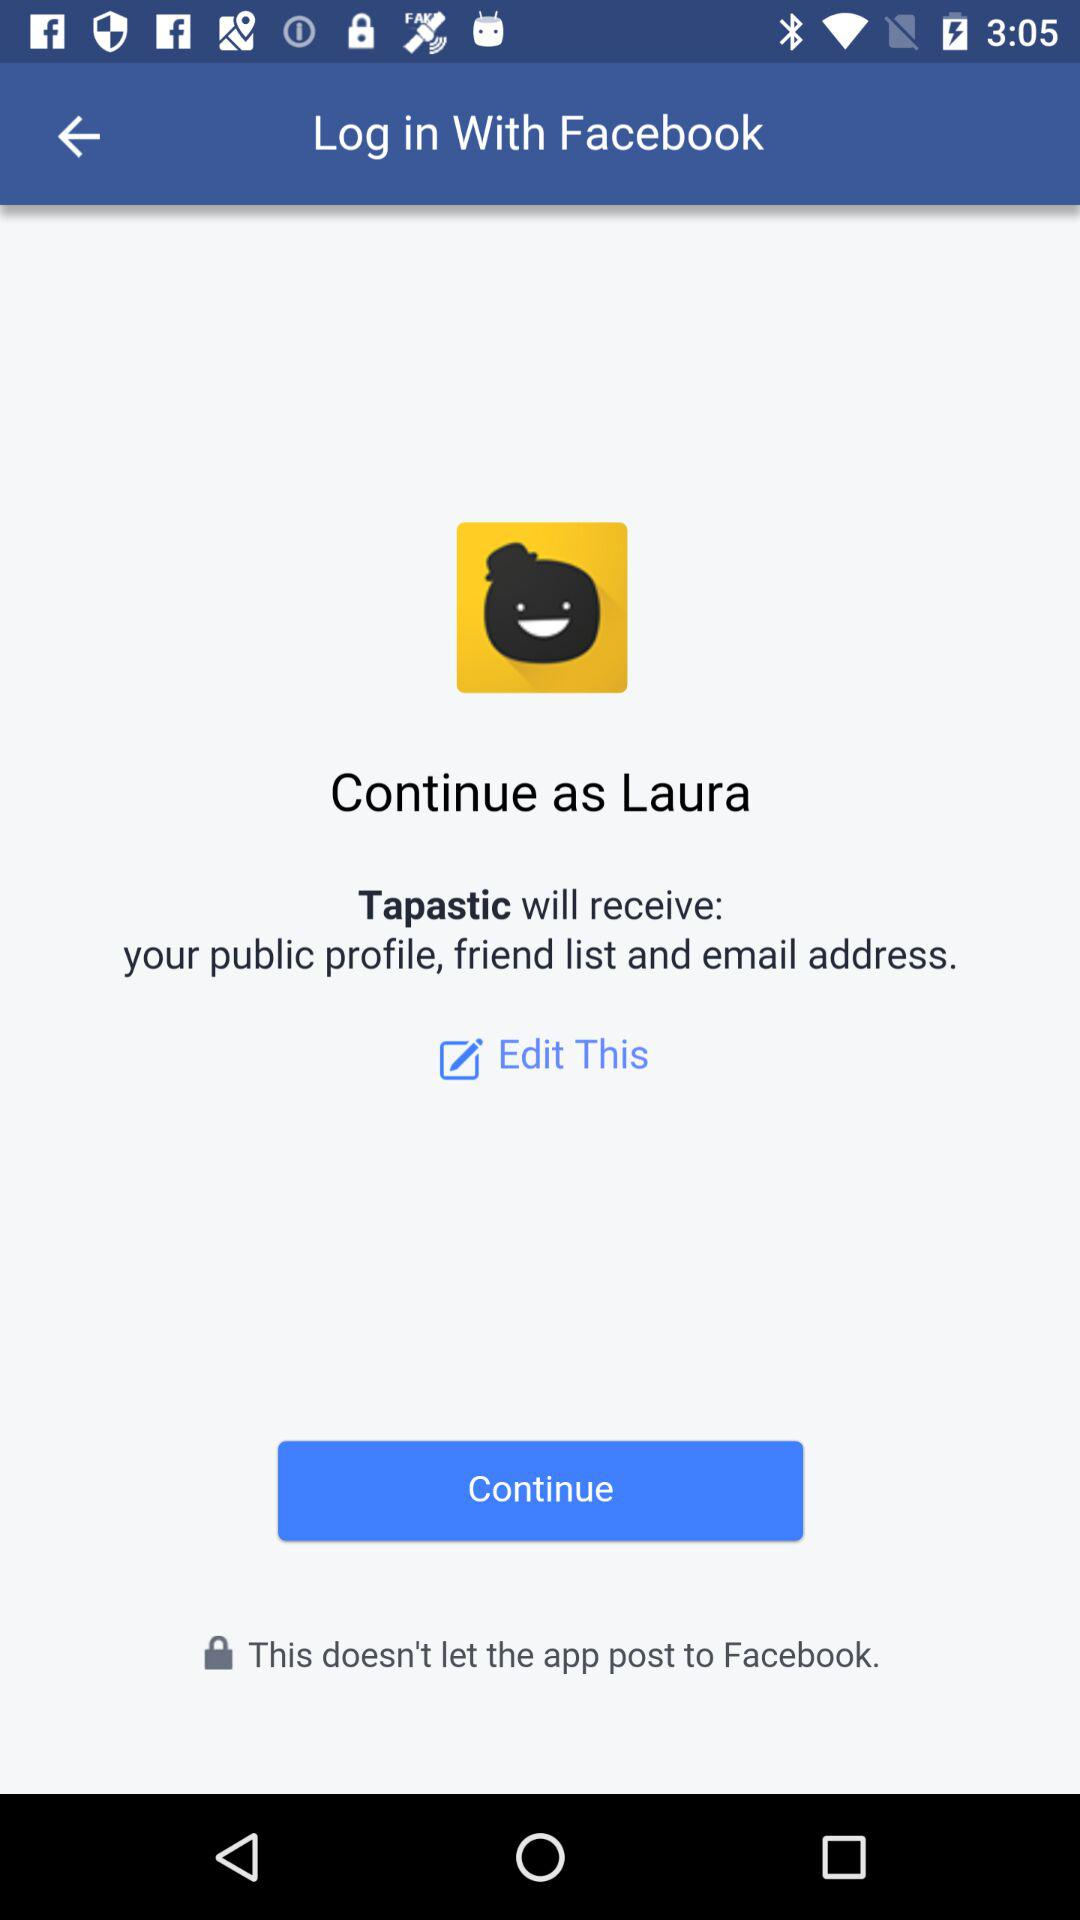What application is asking for permission? The application asking for permission is "Tapastic". 